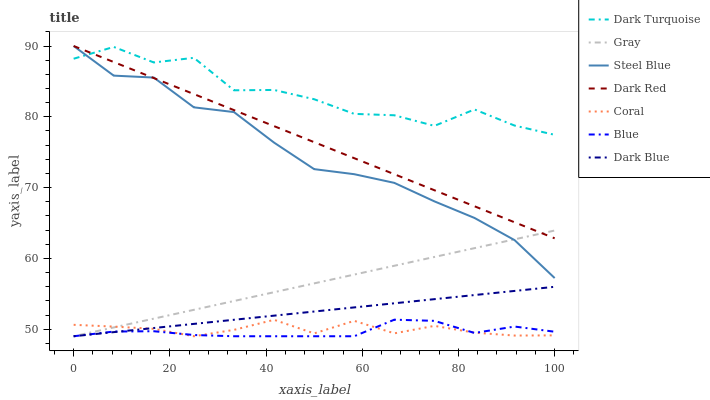Does Blue have the minimum area under the curve?
Answer yes or no. Yes. Does Dark Turquoise have the maximum area under the curve?
Answer yes or no. Yes. Does Gray have the minimum area under the curve?
Answer yes or no. No. Does Gray have the maximum area under the curve?
Answer yes or no. No. Is Gray the smoothest?
Answer yes or no. Yes. Is Dark Turquoise the roughest?
Answer yes or no. Yes. Is Dark Turquoise the smoothest?
Answer yes or no. No. Is Gray the roughest?
Answer yes or no. No. Does Blue have the lowest value?
Answer yes or no. Yes. Does Dark Turquoise have the lowest value?
Answer yes or no. No. Does Dark Red have the highest value?
Answer yes or no. Yes. Does Gray have the highest value?
Answer yes or no. No. Is Blue less than Dark Red?
Answer yes or no. Yes. Is Dark Turquoise greater than Gray?
Answer yes or no. Yes. Does Blue intersect Dark Blue?
Answer yes or no. Yes. Is Blue less than Dark Blue?
Answer yes or no. No. Is Blue greater than Dark Blue?
Answer yes or no. No. Does Blue intersect Dark Red?
Answer yes or no. No. 